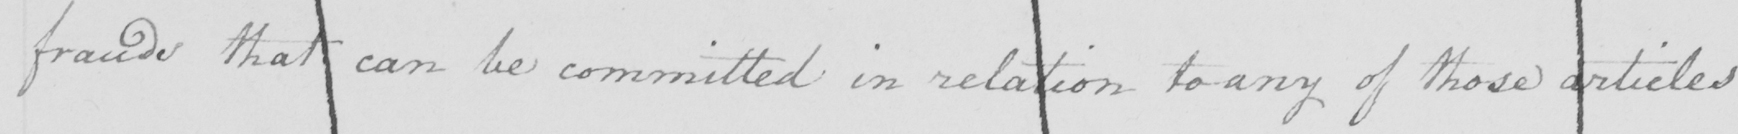What text is written in this handwritten line? frauds that can be committed in relation to any of those articles 